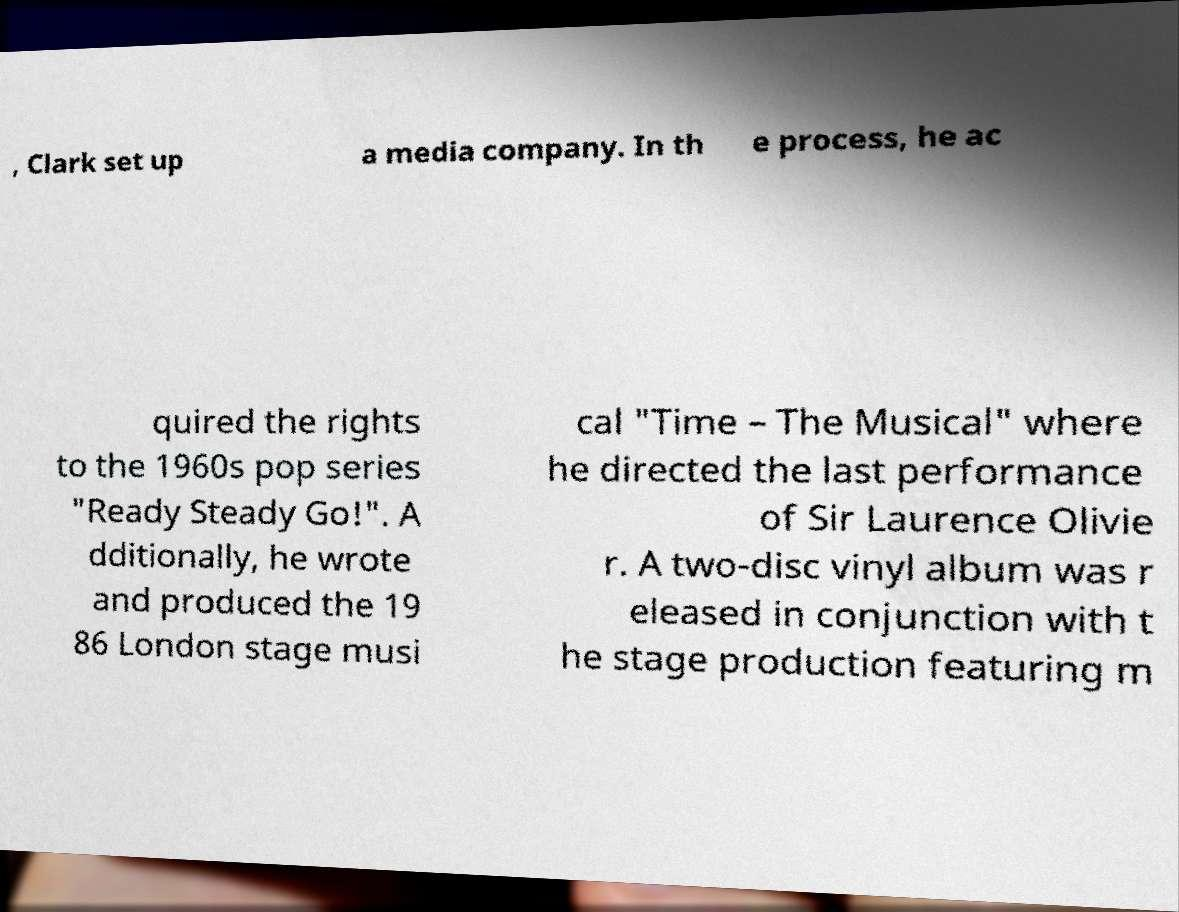Can you accurately transcribe the text from the provided image for me? , Clark set up a media company. In th e process, he ac quired the rights to the 1960s pop series "Ready Steady Go!". A dditionally, he wrote and produced the 19 86 London stage musi cal "Time – The Musical" where he directed the last performance of Sir Laurence Olivie r. A two-disc vinyl album was r eleased in conjunction with t he stage production featuring m 